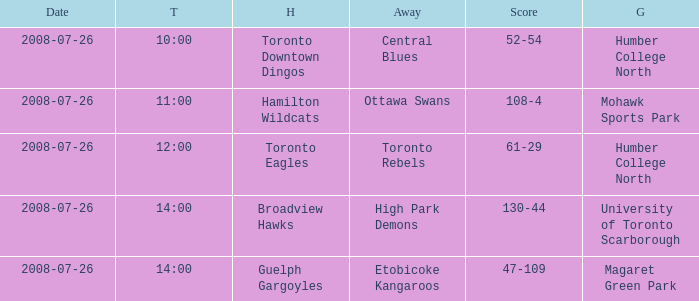Who has the Home Score of 52-54? Toronto Downtown Dingos. 